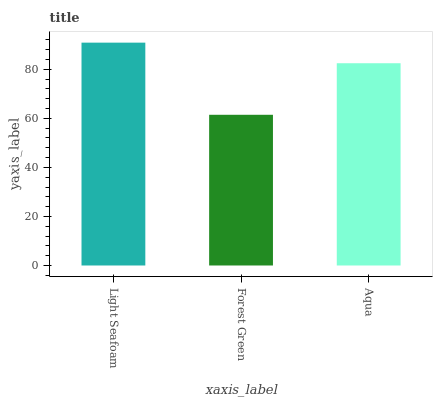Is Aqua the minimum?
Answer yes or no. No. Is Aqua the maximum?
Answer yes or no. No. Is Aqua greater than Forest Green?
Answer yes or no. Yes. Is Forest Green less than Aqua?
Answer yes or no. Yes. Is Forest Green greater than Aqua?
Answer yes or no. No. Is Aqua less than Forest Green?
Answer yes or no. No. Is Aqua the high median?
Answer yes or no. Yes. Is Aqua the low median?
Answer yes or no. Yes. Is Forest Green the high median?
Answer yes or no. No. Is Forest Green the low median?
Answer yes or no. No. 